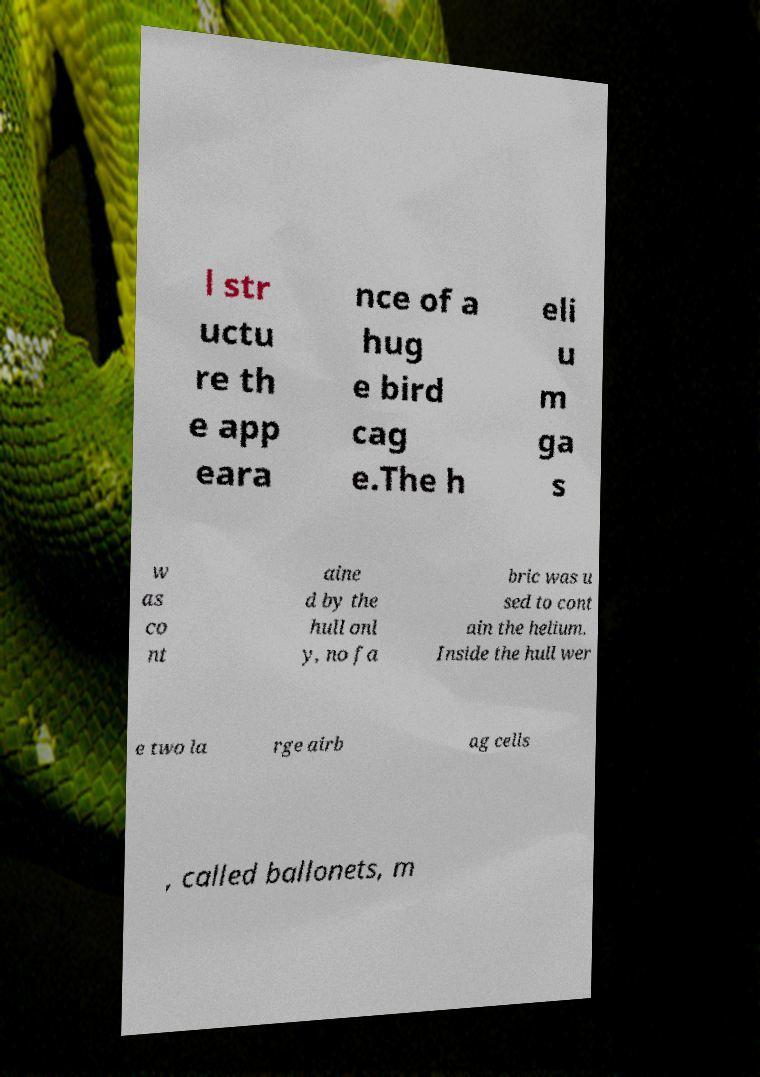Can you accurately transcribe the text from the provided image for me? l str uctu re th e app eara nce of a hug e bird cag e.The h eli u m ga s w as co nt aine d by the hull onl y, no fa bric was u sed to cont ain the helium. Inside the hull wer e two la rge airb ag cells , called ballonets, m 